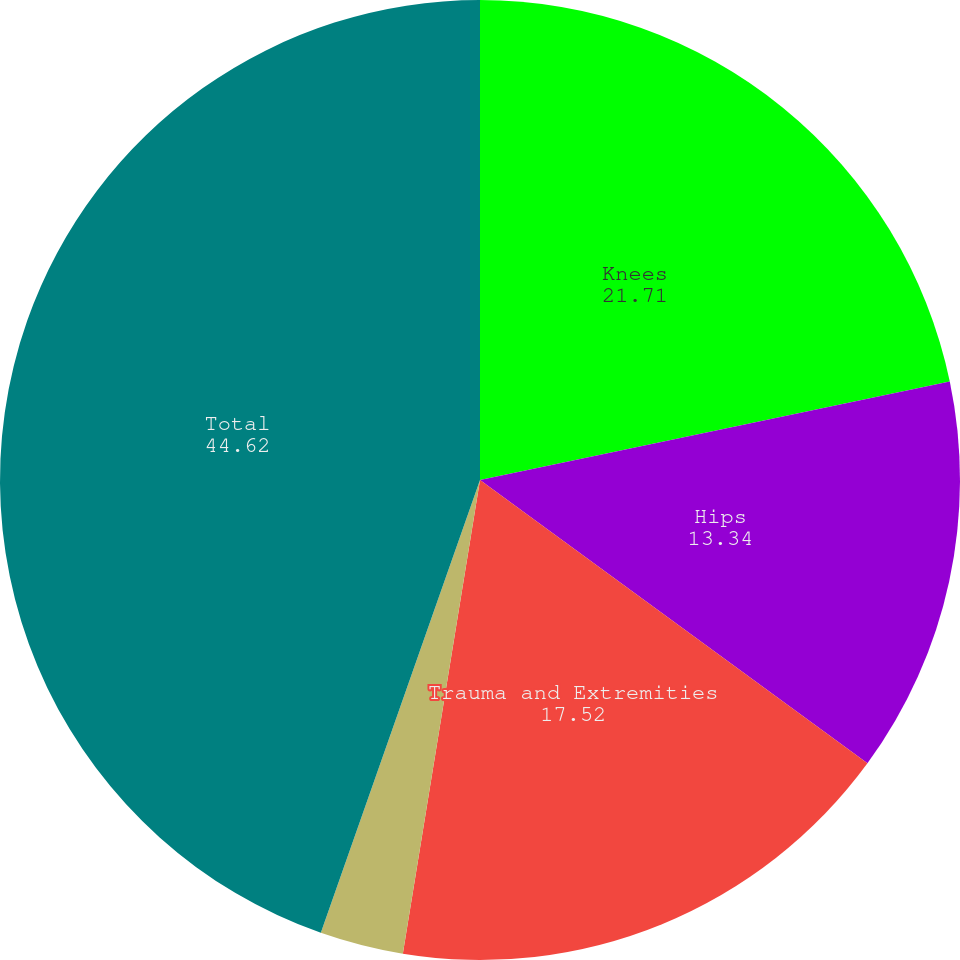<chart> <loc_0><loc_0><loc_500><loc_500><pie_chart><fcel>Knees<fcel>Hips<fcel>Trauma and Extremities<fcel>Other<fcel>Total<nl><fcel>21.71%<fcel>13.34%<fcel>17.52%<fcel>2.81%<fcel>44.62%<nl></chart> 